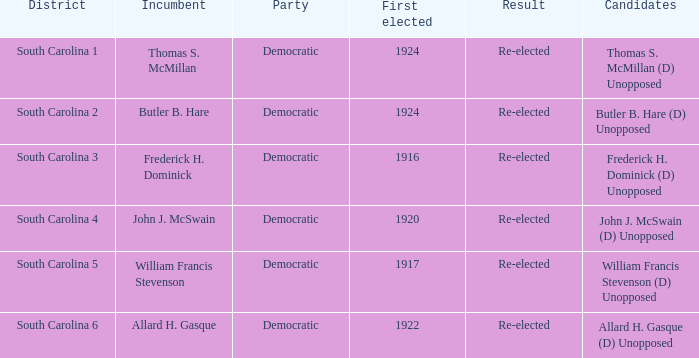What is the complete sum of conclusions where the district is south carolina 5? 1.0. 